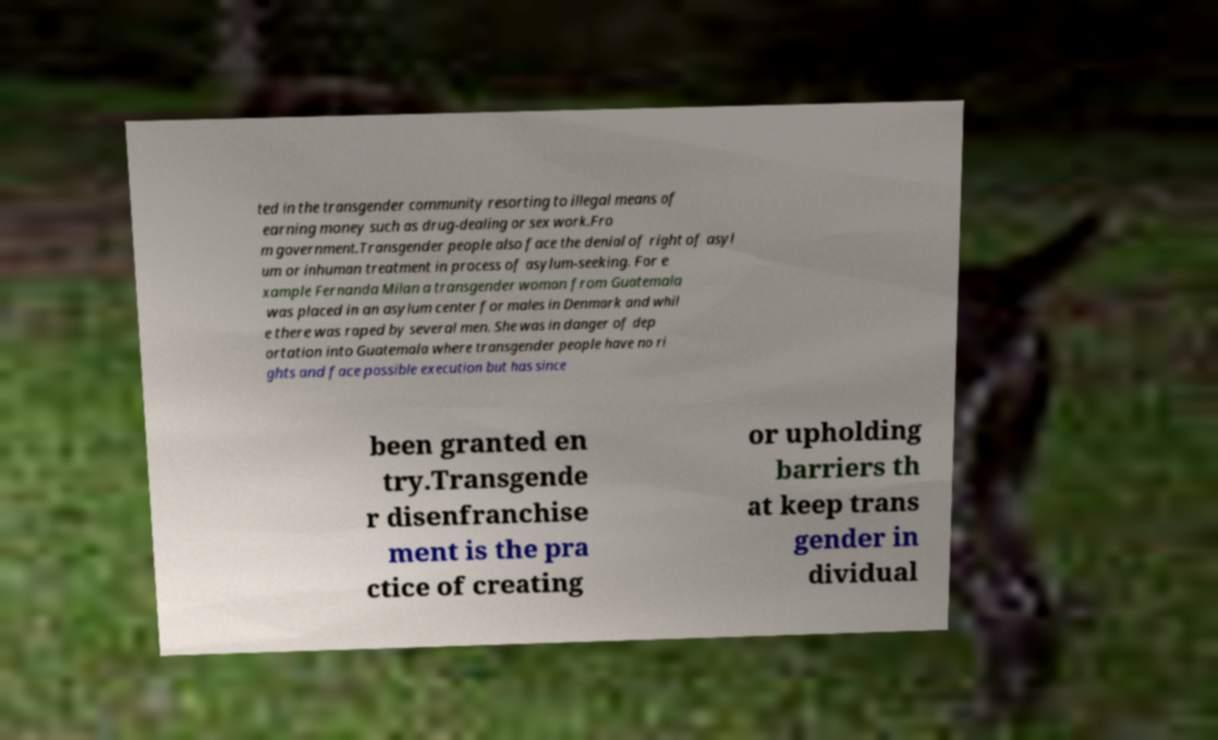Can you accurately transcribe the text from the provided image for me? ted in the transgender community resorting to illegal means of earning money such as drug-dealing or sex work.Fro m government.Transgender people also face the denial of right of asyl um or inhuman treatment in process of asylum-seeking. For e xample Fernanda Milan a transgender woman from Guatemala was placed in an asylum center for males in Denmark and whil e there was raped by several men. She was in danger of dep ortation into Guatemala where transgender people have no ri ghts and face possible execution but has since been granted en try.Transgende r disenfranchise ment is the pra ctice of creating or upholding barriers th at keep trans gender in dividual 